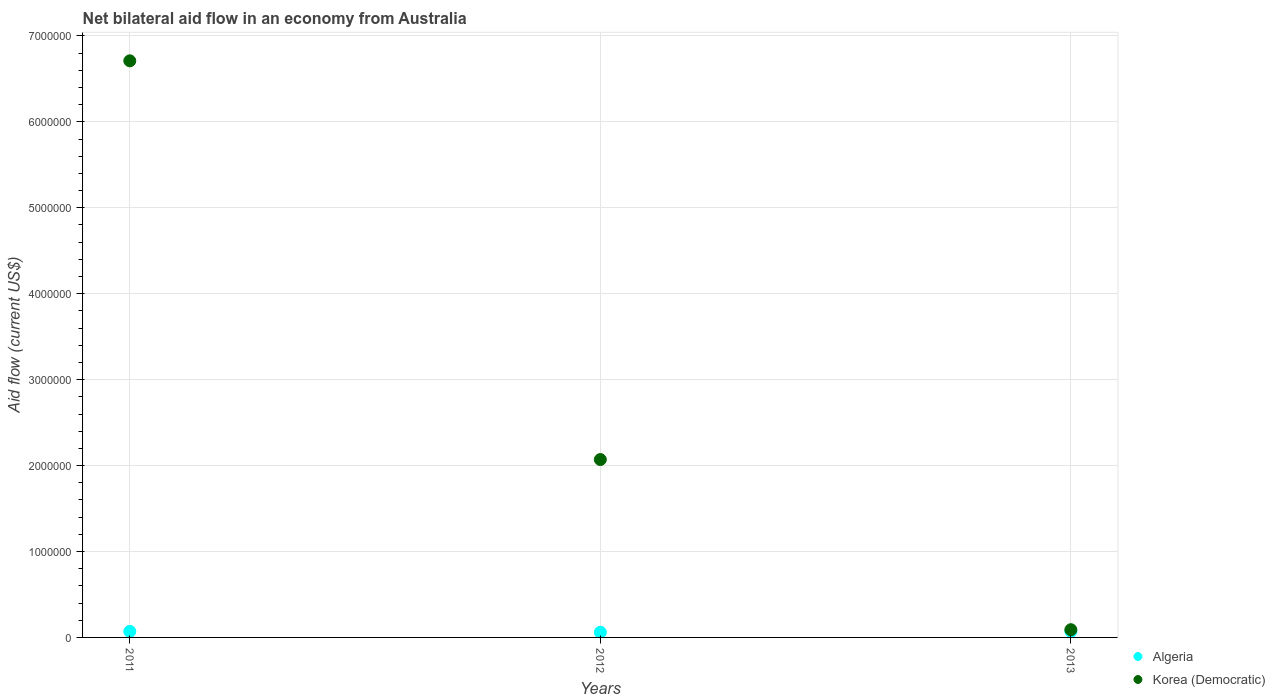Is the number of dotlines equal to the number of legend labels?
Your answer should be very brief. Yes. What is the net bilateral aid flow in Korea (Democratic) in 2012?
Keep it short and to the point. 2.07e+06. Across all years, what is the maximum net bilateral aid flow in Algeria?
Offer a very short reply. 7.00e+04. Across all years, what is the minimum net bilateral aid flow in Algeria?
Ensure brevity in your answer.  6.00e+04. In which year was the net bilateral aid flow in Korea (Democratic) minimum?
Ensure brevity in your answer.  2013. What is the total net bilateral aid flow in Korea (Democratic) in the graph?
Your response must be concise. 8.87e+06. What is the difference between the net bilateral aid flow in Korea (Democratic) in 2011 and the net bilateral aid flow in Algeria in 2013?
Give a very brief answer. 6.64e+06. What is the average net bilateral aid flow in Algeria per year?
Offer a very short reply. 6.67e+04. In the year 2012, what is the difference between the net bilateral aid flow in Korea (Democratic) and net bilateral aid flow in Algeria?
Your answer should be very brief. 2.01e+06. In how many years, is the net bilateral aid flow in Algeria greater than 1400000 US$?
Offer a very short reply. 0. What is the ratio of the net bilateral aid flow in Korea (Democratic) in 2011 to that in 2012?
Provide a short and direct response. 3.24. What is the difference between the highest and the lowest net bilateral aid flow in Korea (Democratic)?
Provide a short and direct response. 6.62e+06. Is the sum of the net bilateral aid flow in Korea (Democratic) in 2011 and 2013 greater than the maximum net bilateral aid flow in Algeria across all years?
Provide a succinct answer. Yes. Does the net bilateral aid flow in Algeria monotonically increase over the years?
Give a very brief answer. No. Is the net bilateral aid flow in Korea (Democratic) strictly greater than the net bilateral aid flow in Algeria over the years?
Keep it short and to the point. Yes. Is the net bilateral aid flow in Korea (Democratic) strictly less than the net bilateral aid flow in Algeria over the years?
Your response must be concise. No. How many years are there in the graph?
Give a very brief answer. 3. What is the difference between two consecutive major ticks on the Y-axis?
Your answer should be compact. 1.00e+06. Are the values on the major ticks of Y-axis written in scientific E-notation?
Offer a terse response. No. Does the graph contain any zero values?
Your response must be concise. No. Does the graph contain grids?
Your answer should be very brief. Yes. How many legend labels are there?
Give a very brief answer. 2. What is the title of the graph?
Give a very brief answer. Net bilateral aid flow in an economy from Australia. What is the label or title of the Y-axis?
Make the answer very short. Aid flow (current US$). What is the Aid flow (current US$) of Korea (Democratic) in 2011?
Your answer should be very brief. 6.71e+06. What is the Aid flow (current US$) of Algeria in 2012?
Offer a terse response. 6.00e+04. What is the Aid flow (current US$) in Korea (Democratic) in 2012?
Offer a very short reply. 2.07e+06. Across all years, what is the maximum Aid flow (current US$) of Algeria?
Keep it short and to the point. 7.00e+04. Across all years, what is the maximum Aid flow (current US$) in Korea (Democratic)?
Keep it short and to the point. 6.71e+06. Across all years, what is the minimum Aid flow (current US$) of Algeria?
Ensure brevity in your answer.  6.00e+04. Across all years, what is the minimum Aid flow (current US$) in Korea (Democratic)?
Provide a short and direct response. 9.00e+04. What is the total Aid flow (current US$) in Korea (Democratic) in the graph?
Your answer should be compact. 8.87e+06. What is the difference between the Aid flow (current US$) of Algeria in 2011 and that in 2012?
Your answer should be very brief. 10000. What is the difference between the Aid flow (current US$) of Korea (Democratic) in 2011 and that in 2012?
Your answer should be very brief. 4.64e+06. What is the difference between the Aid flow (current US$) of Algeria in 2011 and that in 2013?
Provide a short and direct response. 0. What is the difference between the Aid flow (current US$) in Korea (Democratic) in 2011 and that in 2013?
Your response must be concise. 6.62e+06. What is the difference between the Aid flow (current US$) in Korea (Democratic) in 2012 and that in 2013?
Give a very brief answer. 1.98e+06. What is the difference between the Aid flow (current US$) of Algeria in 2011 and the Aid flow (current US$) of Korea (Democratic) in 2013?
Your answer should be very brief. -2.00e+04. What is the average Aid flow (current US$) of Algeria per year?
Offer a terse response. 6.67e+04. What is the average Aid flow (current US$) in Korea (Democratic) per year?
Provide a short and direct response. 2.96e+06. In the year 2011, what is the difference between the Aid flow (current US$) in Algeria and Aid flow (current US$) in Korea (Democratic)?
Keep it short and to the point. -6.64e+06. In the year 2012, what is the difference between the Aid flow (current US$) in Algeria and Aid flow (current US$) in Korea (Democratic)?
Keep it short and to the point. -2.01e+06. What is the ratio of the Aid flow (current US$) of Korea (Democratic) in 2011 to that in 2012?
Your response must be concise. 3.24. What is the ratio of the Aid flow (current US$) of Algeria in 2011 to that in 2013?
Keep it short and to the point. 1. What is the ratio of the Aid flow (current US$) in Korea (Democratic) in 2011 to that in 2013?
Make the answer very short. 74.56. What is the ratio of the Aid flow (current US$) in Algeria in 2012 to that in 2013?
Keep it short and to the point. 0.86. What is the ratio of the Aid flow (current US$) of Korea (Democratic) in 2012 to that in 2013?
Ensure brevity in your answer.  23. What is the difference between the highest and the second highest Aid flow (current US$) in Korea (Democratic)?
Offer a very short reply. 4.64e+06. What is the difference between the highest and the lowest Aid flow (current US$) in Korea (Democratic)?
Your response must be concise. 6.62e+06. 